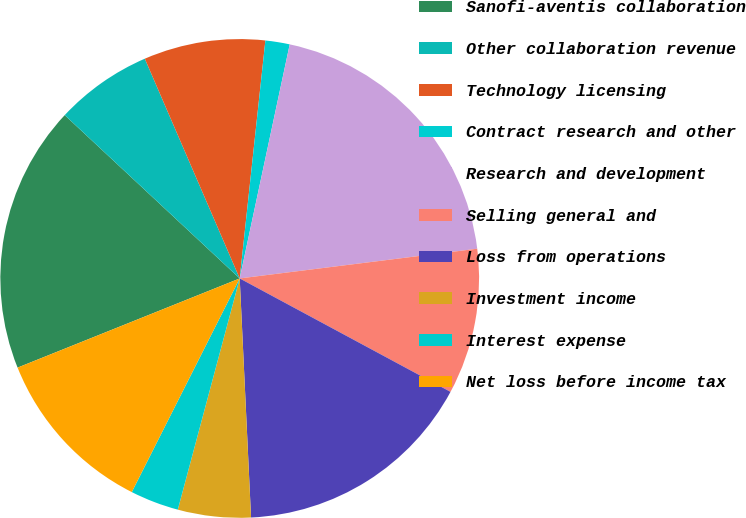<chart> <loc_0><loc_0><loc_500><loc_500><pie_chart><fcel>Sanofi-aventis collaboration<fcel>Other collaboration revenue<fcel>Technology licensing<fcel>Contract research and other<fcel>Research and development<fcel>Selling general and<fcel>Loss from operations<fcel>Investment income<fcel>Interest expense<fcel>Net loss before income tax<nl><fcel>18.03%<fcel>6.56%<fcel>8.2%<fcel>1.64%<fcel>19.67%<fcel>9.84%<fcel>16.39%<fcel>4.92%<fcel>3.28%<fcel>11.48%<nl></chart> 